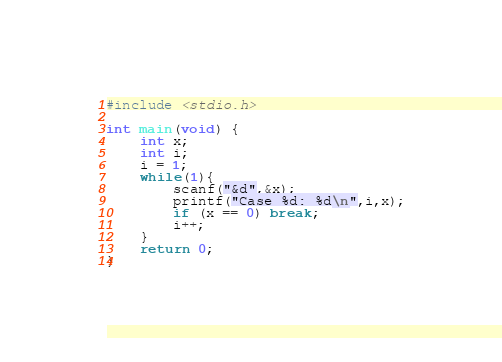<code> <loc_0><loc_0><loc_500><loc_500><_C_>#include <stdio.h>

int main(void) {
	int x;
	int i;
	i = 1;
	while(1){
		scanf("&d",&x);
		printf("Case %d: %d\n",i,x);
		if (x == 0) break;
		i++;
	}
	return 0;
}
</code> 